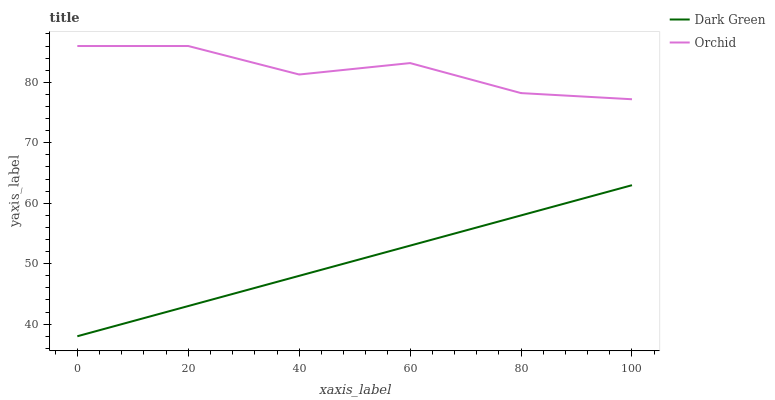Does Dark Green have the minimum area under the curve?
Answer yes or no. Yes. Does Orchid have the maximum area under the curve?
Answer yes or no. Yes. Does Dark Green have the maximum area under the curve?
Answer yes or no. No. Is Dark Green the smoothest?
Answer yes or no. Yes. Is Orchid the roughest?
Answer yes or no. Yes. Is Dark Green the roughest?
Answer yes or no. No. Does Dark Green have the lowest value?
Answer yes or no. Yes. Does Orchid have the highest value?
Answer yes or no. Yes. Does Dark Green have the highest value?
Answer yes or no. No. Is Dark Green less than Orchid?
Answer yes or no. Yes. Is Orchid greater than Dark Green?
Answer yes or no. Yes. Does Dark Green intersect Orchid?
Answer yes or no. No. 